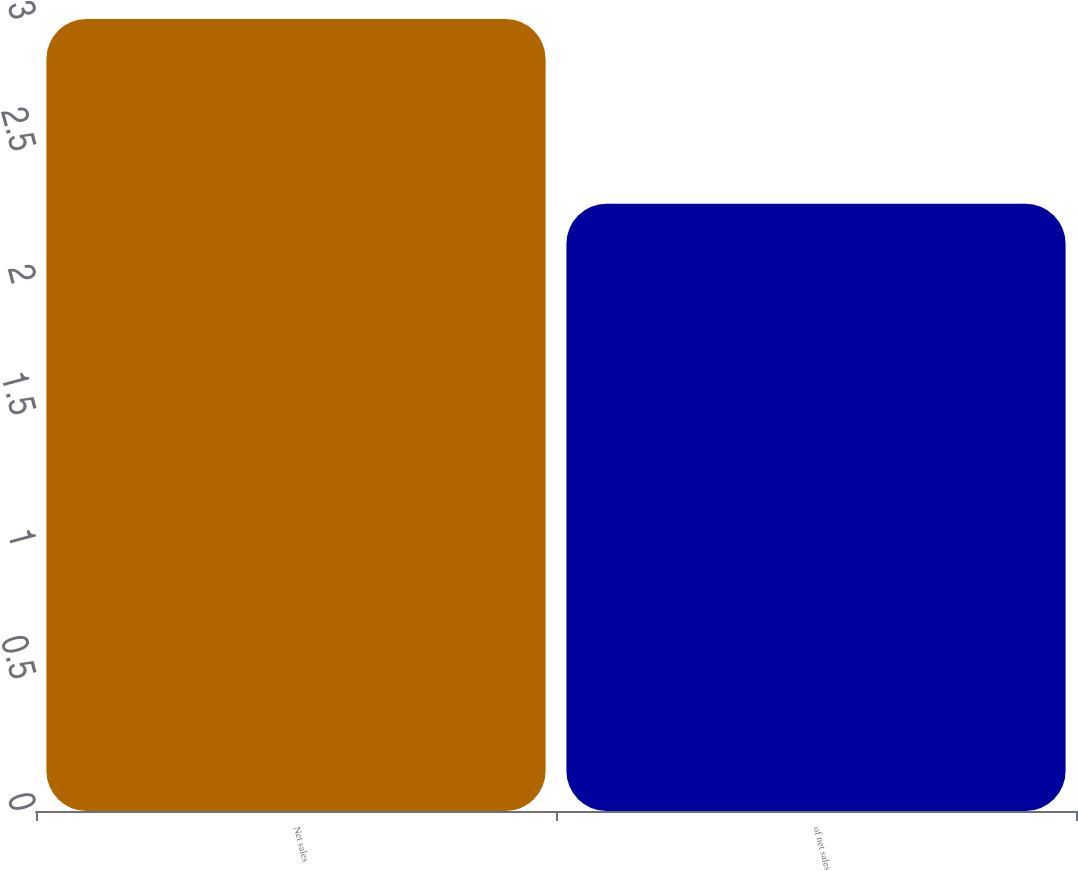Convert chart to OTSL. <chart><loc_0><loc_0><loc_500><loc_500><bar_chart><fcel>Net sales<fcel>of net sales<nl><fcel>3<fcel>2.3<nl></chart> 